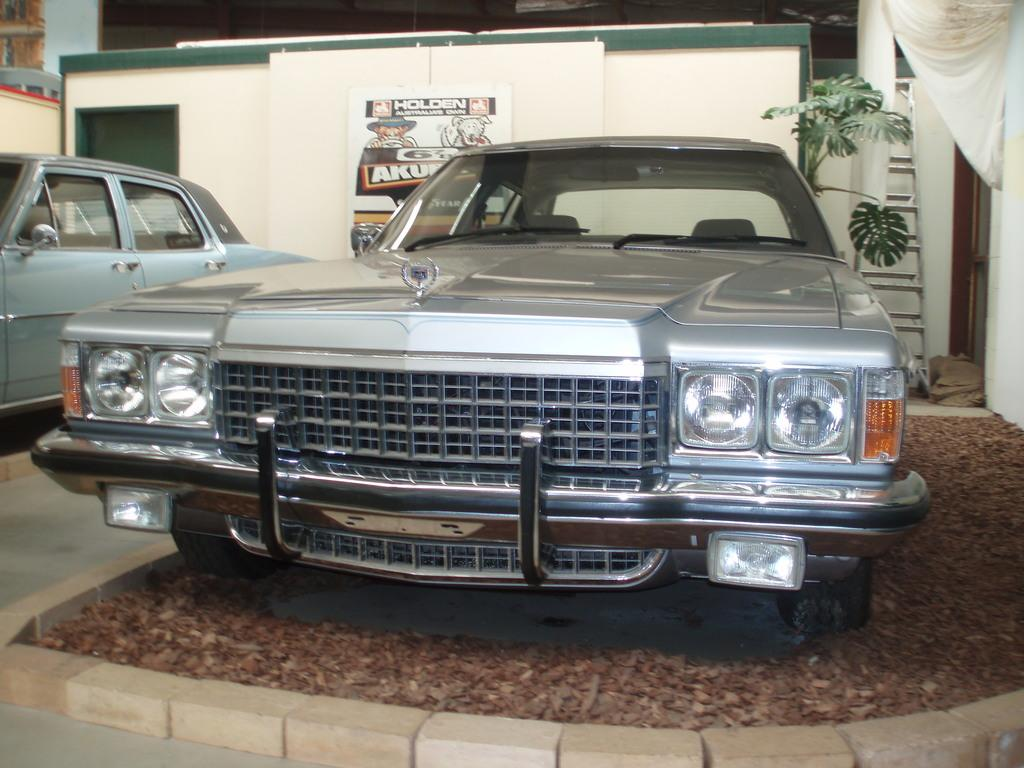How many cars are present in the image? There are two cars in the image. What can be seen in the background of the image? There is a wall and a plant in the background of the image. What type of feast is being prepared by the father in the image? There is no father or feast present in the image; it only features two cars and a background with a wall and a plant. 